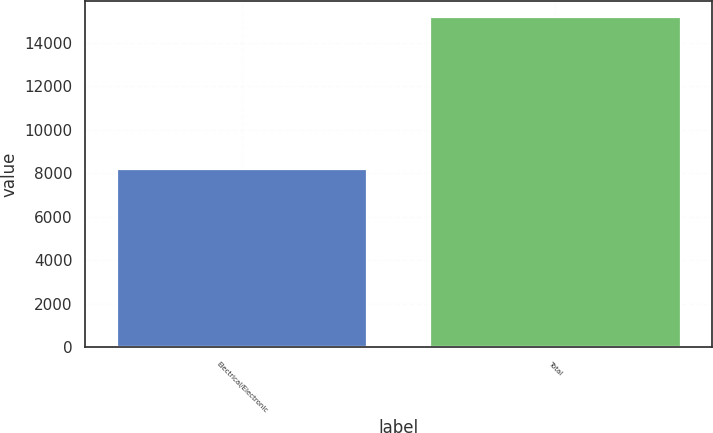Convert chart. <chart><loc_0><loc_0><loc_500><loc_500><bar_chart><fcel>Electrical/Electronic<fcel>Total<nl><fcel>8180<fcel>15165<nl></chart> 